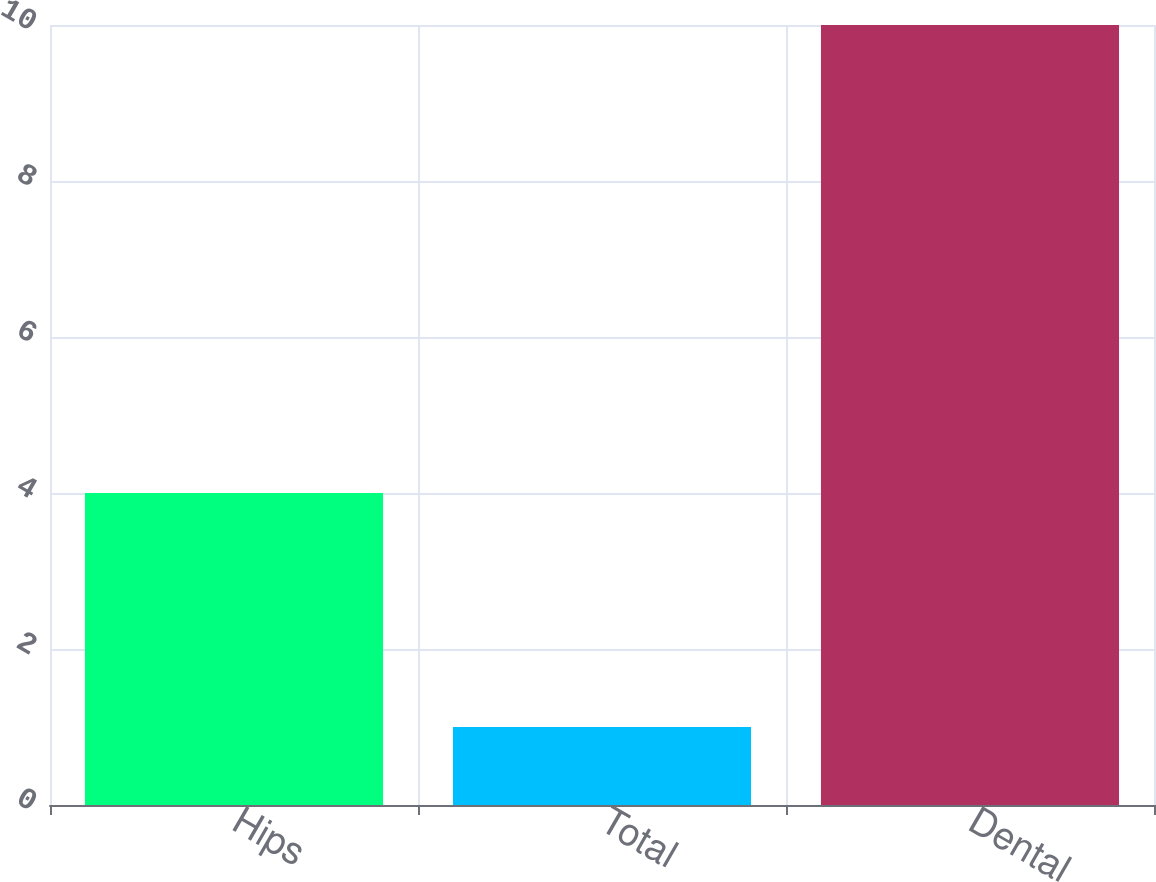Convert chart. <chart><loc_0><loc_0><loc_500><loc_500><bar_chart><fcel>Hips<fcel>Total<fcel>Dental<nl><fcel>4<fcel>1<fcel>10<nl></chart> 